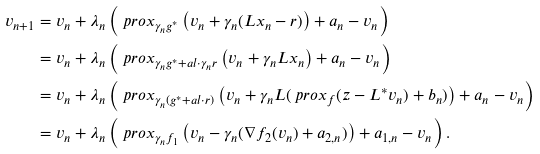<formula> <loc_0><loc_0><loc_500><loc_500>v _ { n + 1 } & = v _ { n } + \lambda _ { n } \left ( \ p r o x _ { \gamma _ { n } g ^ { * } } \left ( v _ { n } + \gamma _ { n } ( L x _ { n } - r ) \right ) + a _ { n } - v _ { n } \right ) \\ & = v _ { n } + \lambda _ { n } \left ( \ p r o x _ { \gamma _ { n } g ^ { * } + a l { \cdot } { \gamma _ { n } r } } \left ( v _ { n } + \gamma _ { n } L x _ { n } \right ) + a _ { n } - v _ { n } \right ) \\ & = v _ { n } + \lambda _ { n } \left ( \ p r o x _ { \gamma _ { n } ( g ^ { * } + a l { \cdot } { r } ) } \left ( v _ { n } + \gamma _ { n } L ( \ p r o x _ { f } ( z - L ^ { * } v _ { n } ) + b _ { n } ) \right ) + a _ { n } - v _ { n } \right ) \\ & = v _ { n } + \lambda _ { n } \left ( \ p r o x _ { \gamma _ { n } f _ { 1 } } \left ( v _ { n } - \gamma _ { n } ( \nabla f _ { 2 } ( v _ { n } ) + a _ { 2 , n } ) \right ) + a _ { 1 , n } - v _ { n } \right ) .</formula> 